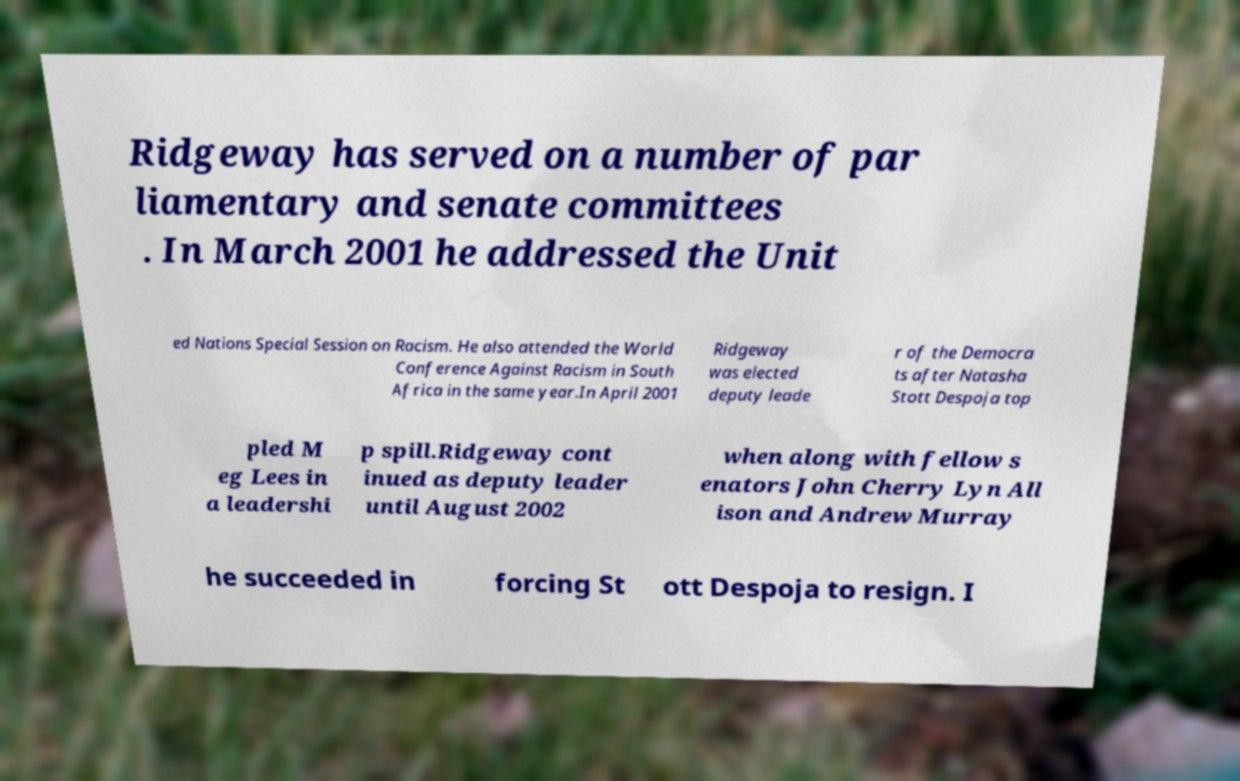For documentation purposes, I need the text within this image transcribed. Could you provide that? Ridgeway has served on a number of par liamentary and senate committees . In March 2001 he addressed the Unit ed Nations Special Session on Racism. He also attended the World Conference Against Racism in South Africa in the same year.In April 2001 Ridgeway was elected deputy leade r of the Democra ts after Natasha Stott Despoja top pled M eg Lees in a leadershi p spill.Ridgeway cont inued as deputy leader until August 2002 when along with fellow s enators John Cherry Lyn All ison and Andrew Murray he succeeded in forcing St ott Despoja to resign. I 